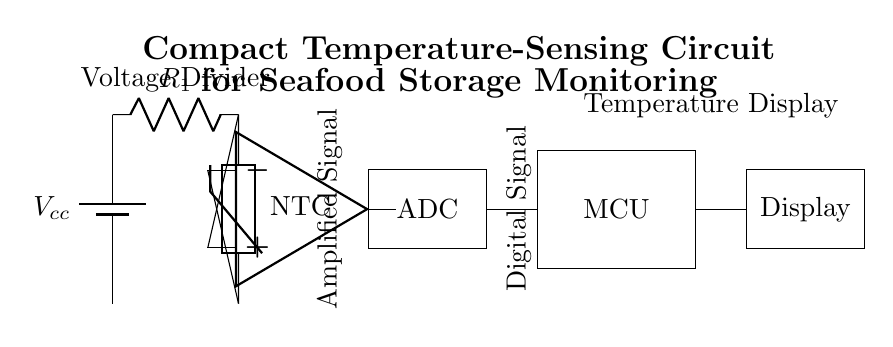What are the components in this circuit? The circuit diagram includes a battery, a thermistor, a resistor, an operational amplifier, an ADC, and a microcontroller, along with a display. Each part is represented visually and labeled accordingly.
Answer: Battery, thermistor, resistor, operational amplifier, ADC, microcontroller, display What type of sensor is used in the circuit? The sensor depicted in the circuit is an NTC thermistor, commonly used for temperature sensing due to its characteristics of decreasing resistance with increasing temperature.
Answer: NTC thermistor How is the output signal amplified in this circuit? The output signal is amplified by the operational amplifier, which takes the small signal from the thermistor and enhances it for further processing. This is indicated by the connection of the thermistor's output to the inverting and non-inverting inputs of the op-amp.
Answer: Operational amplifier What does the ADC do in this circuit? The ADC, or Analog-to-Digital Converter, transforms the amplified analog signal from the operational amplifier into a digital format that the microcontroller can process. This conversion allows for more advanced monitoring and analysis of the temperature data.
Answer: Convert analog to digital What is the purpose of the display in this setup? The display is used to show the temperature readings gathered from the ADC processed by the microcontroller. It provides a user-friendly interface for monitoring the temperature of the seafood storage conditions.
Answer: Show temperature readings Why is a voltage divider used in this circuit? The voltage divider created by the resistor and thermistor allows for precise voltage measurement corresponding to temperature changes, aiding the operational amplifier's ability to amplify the signal appropriately for more accurate readings.
Answer: To measure voltage for temperature What is the main function of the microcontroller in the circuit? The microcontroller receives the digital signal from the ADC and processes it, executing tasks such as converting the digital signal into readable temperature values for display, and potentially triggering alerts based on predefined temperature thresholds.
Answer: Process digital signal 